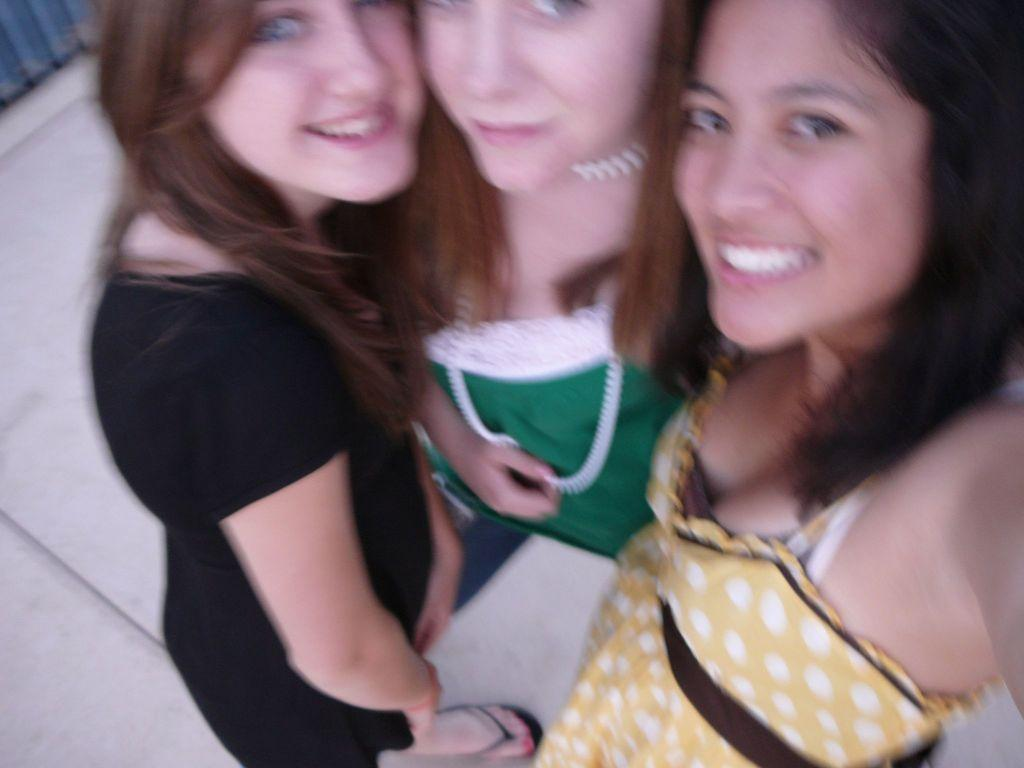How many women are present in the image? There are three women in the image. What is the position of the women in the image? The women are standing on the floor. What are the women wearing in the image? The women are wearing colorful dresses. What type of chalk is the woman holding in the image? There is no chalk present in the image. Are the women driving any vehicles in the image? No, the women are not driving any vehicles in the image. 